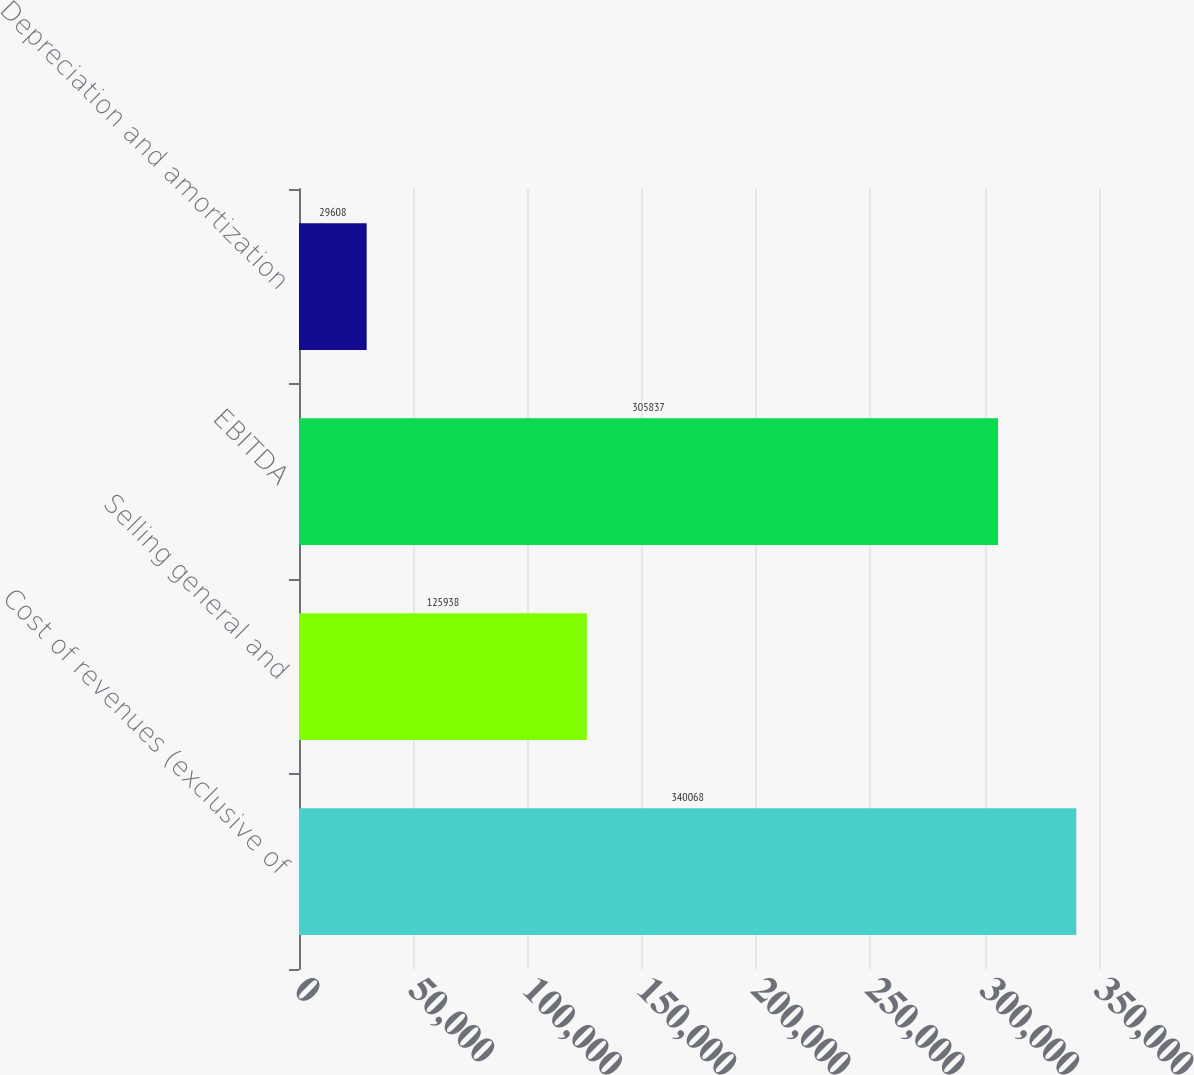<chart> <loc_0><loc_0><loc_500><loc_500><bar_chart><fcel>Cost of revenues (exclusive of<fcel>Selling general and<fcel>EBITDA<fcel>Depreciation and amortization<nl><fcel>340068<fcel>125938<fcel>305837<fcel>29608<nl></chart> 